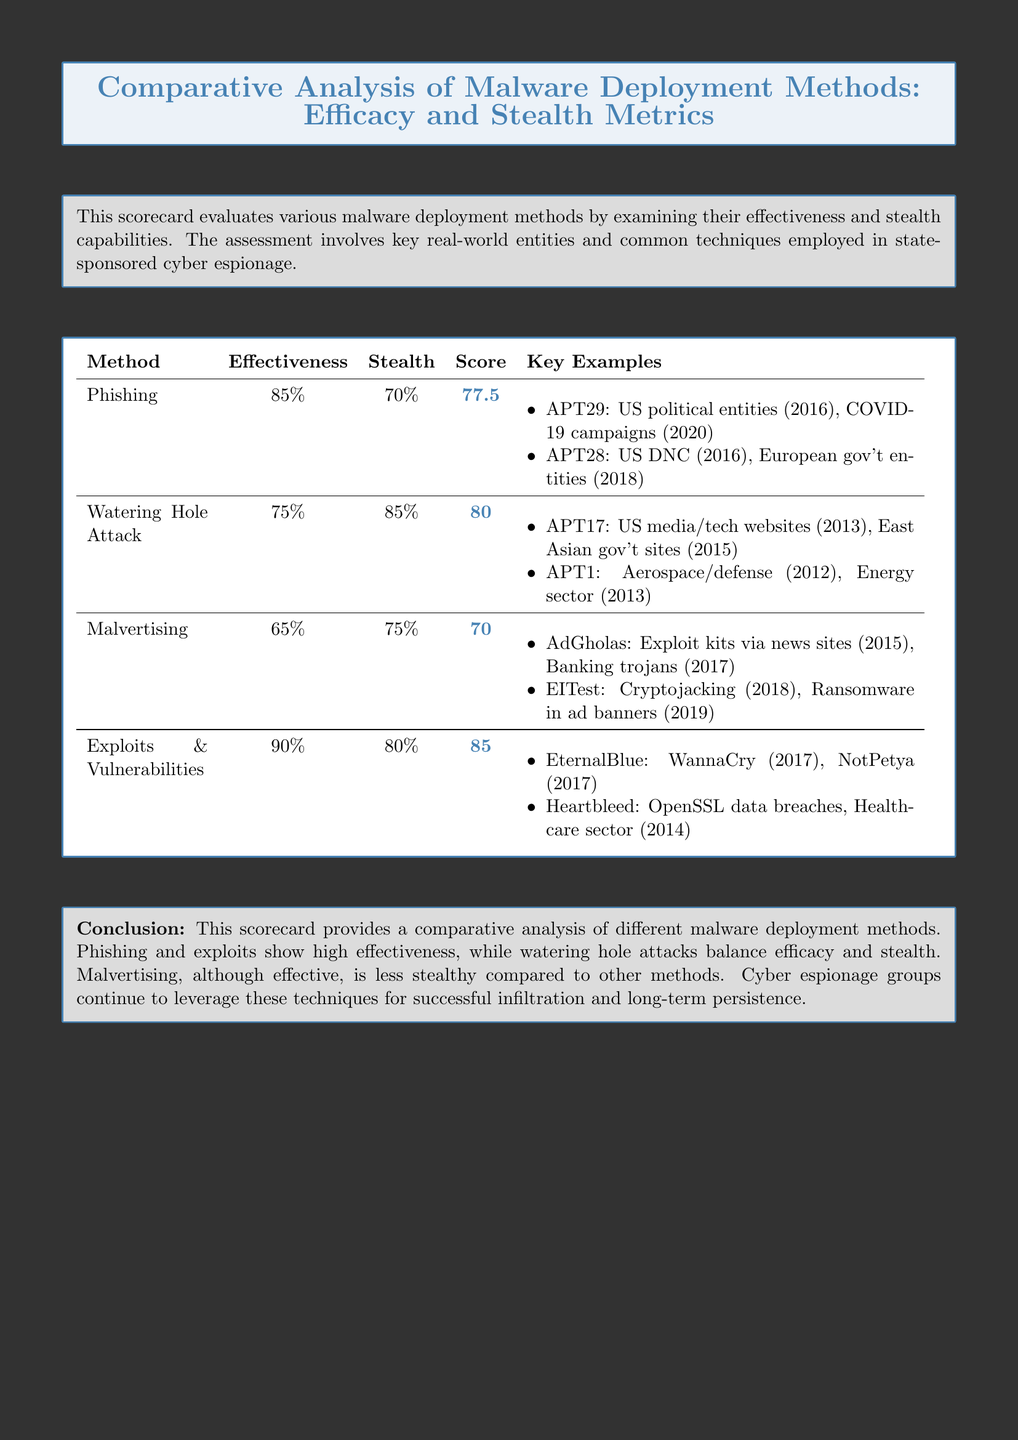What is the score for Phishing? The score for Phishing is given in the table as 77.5.
Answer: 77.5 What is the effectiveness percentage of Exploits & Vulnerabilities? The effectiveness percentage for Exploits & Vulnerabilities is listed in the table as 90%.
Answer: 90% Which method has the highest effectiveness? By comparing the effectiveness values in the table, Exploits & Vulnerabilities has the highest effectiveness at 90%.
Answer: Exploits & Vulnerabilities What key example is associated with Malvertising? The key examples associated with Malvertising include AdGholas and EITest as specified in the table.
Answer: AdGholas, EITest Which deployment method has the lowest score? The deployment method with the lowest score, based on the table, is Malvertising with a score of 70.
Answer: Malvertising What is the conclusion regarding the effectiveness and stealth of watering hole attacks? The conclusion states that watering hole attacks balance efficacy and stealth.
Answer: Balance efficacy and stealth What was the year of the WannaCry attack? The WannaCry attack year is noted in the key examples as 2017.
Answer: 2017 Which malware deployment method has the highest stealth percentage? The stealth percentage is highest for Watering Hole Attack at 85%.
Answer: Watering Hole Attack 